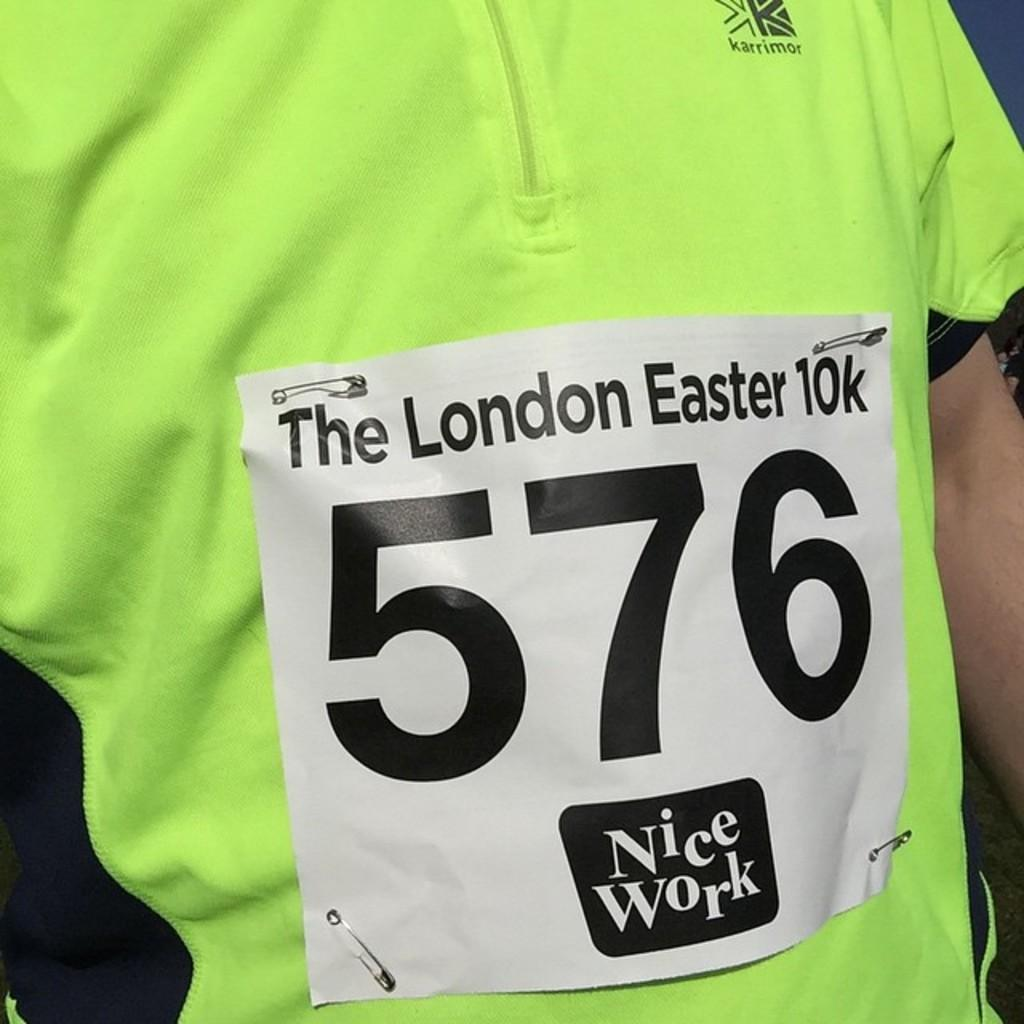Who or what is present in the image? There is a person in the image. What is the person wearing? The person is wearing a green color shirt. Is there anything attached to the shirt? Yes, there is a poster with text and a number attached to the shirt. What type of shock can be seen affecting the person in the image? There is no shock present in the image; the person is simply wearing a green color shirt with a poster attached to it. 